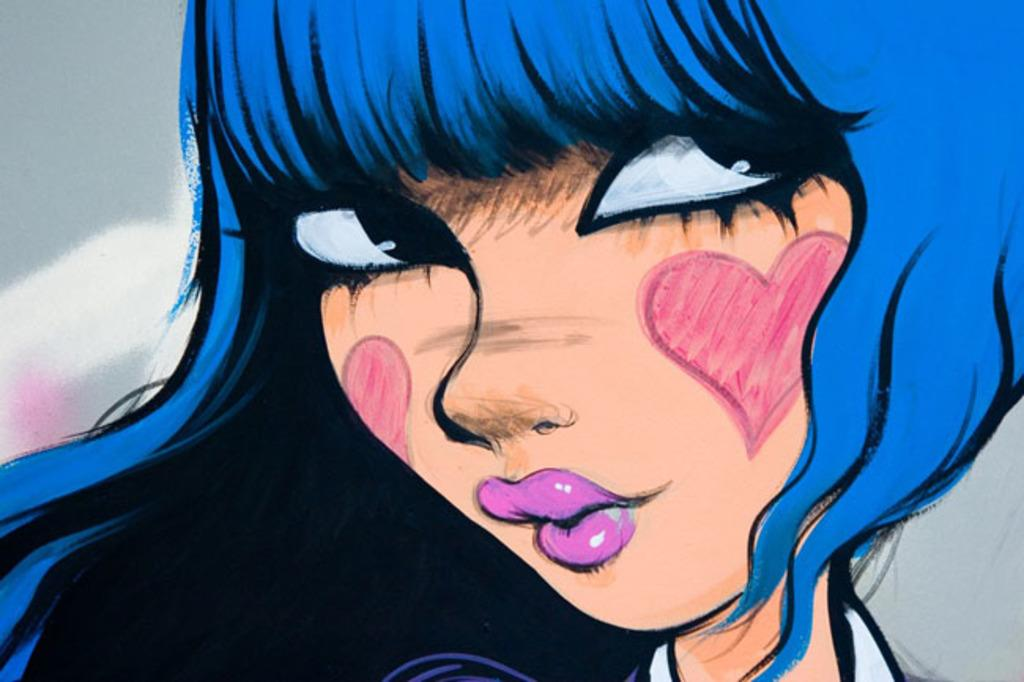What type of content is depicted in the image? There is a cartoon in the image. What grade does the friend sitting in the van give to the cartoon in the image? There is no friend or van present in the image, and therefore no such grade can be given. 